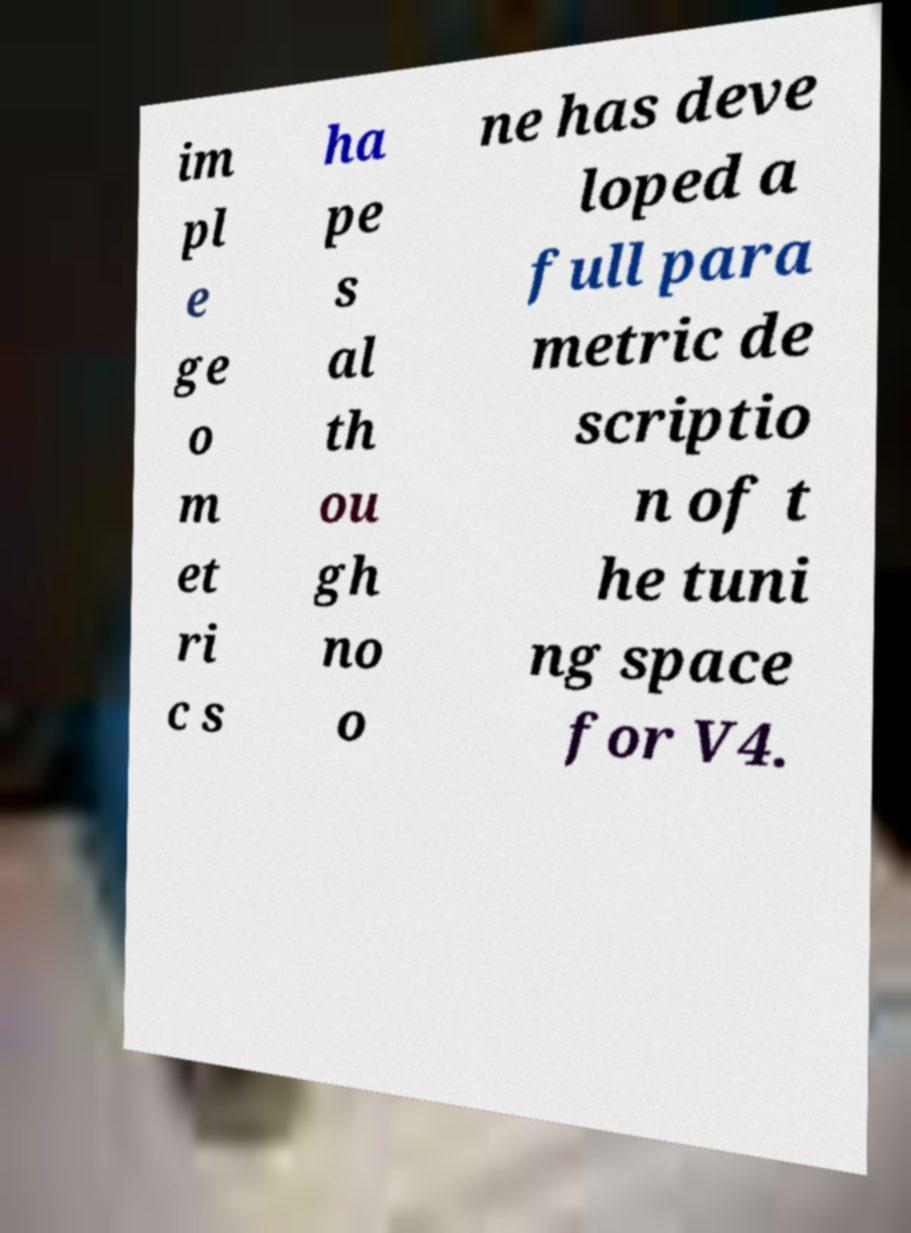For documentation purposes, I need the text within this image transcribed. Could you provide that? im pl e ge o m et ri c s ha pe s al th ou gh no o ne has deve loped a full para metric de scriptio n of t he tuni ng space for V4. 